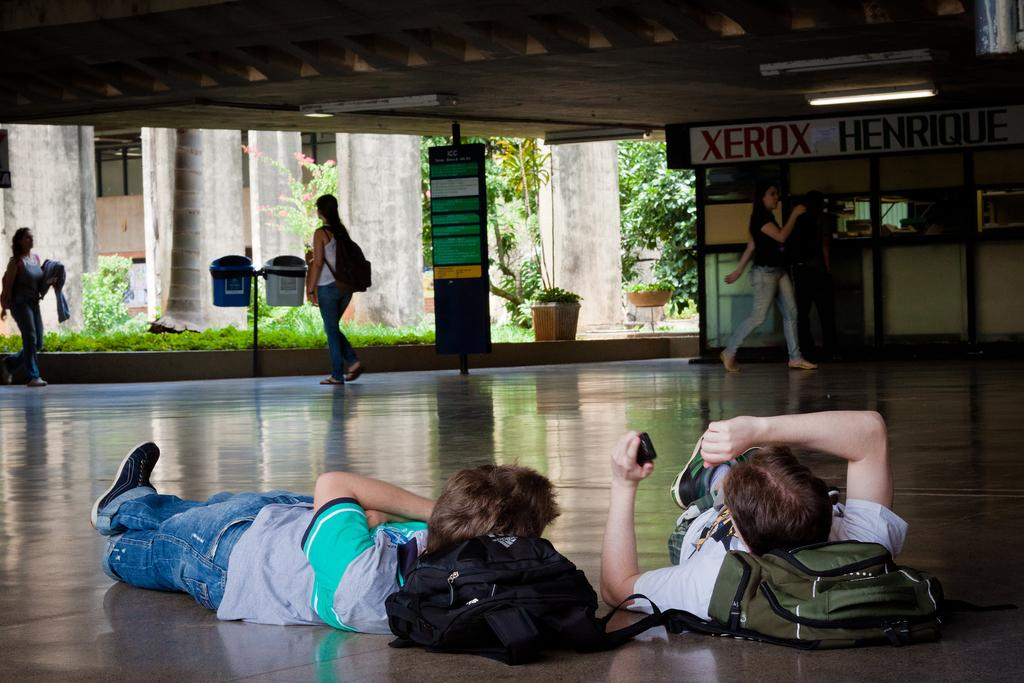<image>
Relay a brief, clear account of the picture shown. students laying down on the floor of a room with banner saying xerox henrique. 